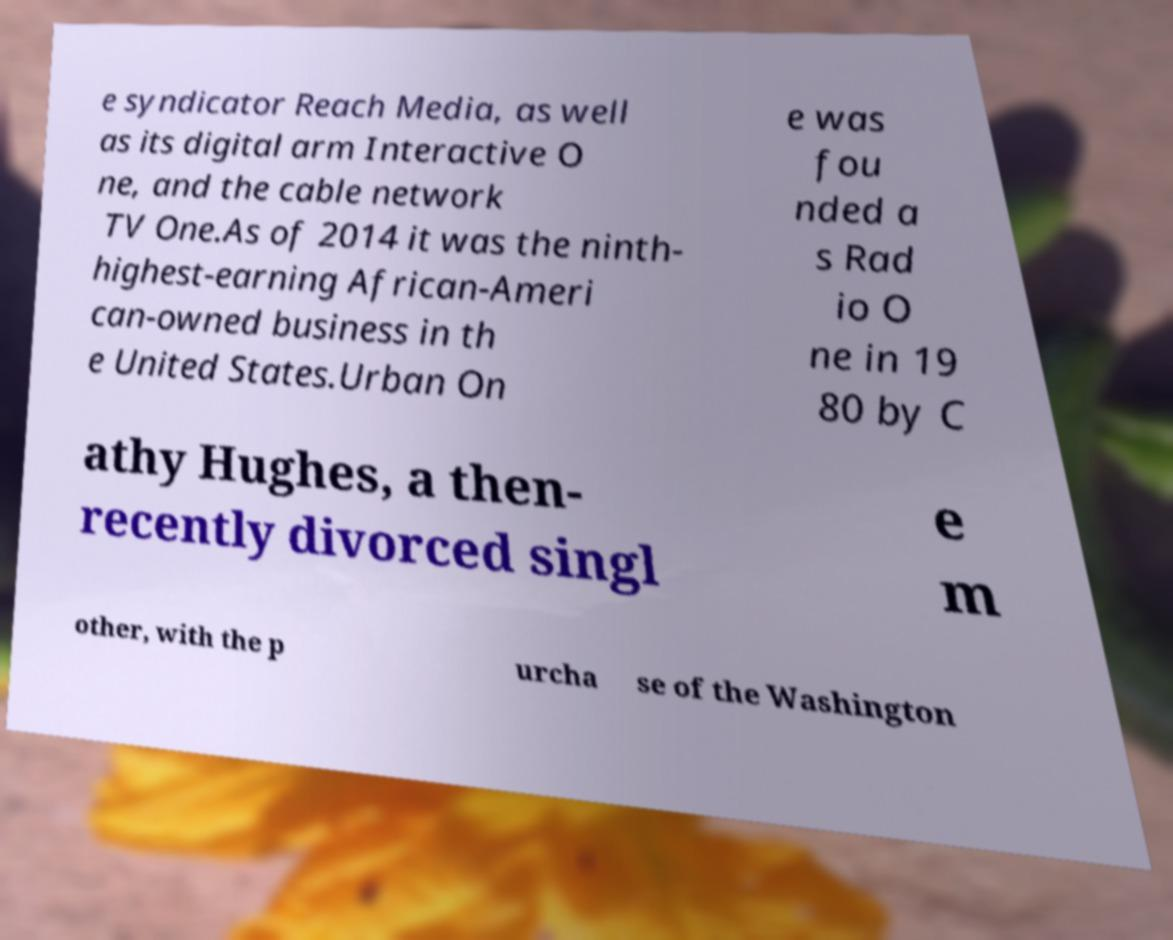I need the written content from this picture converted into text. Can you do that? e syndicator Reach Media, as well as its digital arm Interactive O ne, and the cable network TV One.As of 2014 it was the ninth- highest-earning African-Ameri can-owned business in th e United States.Urban On e was fou nded a s Rad io O ne in 19 80 by C athy Hughes, a then- recently divorced singl e m other, with the p urcha se of the Washington 